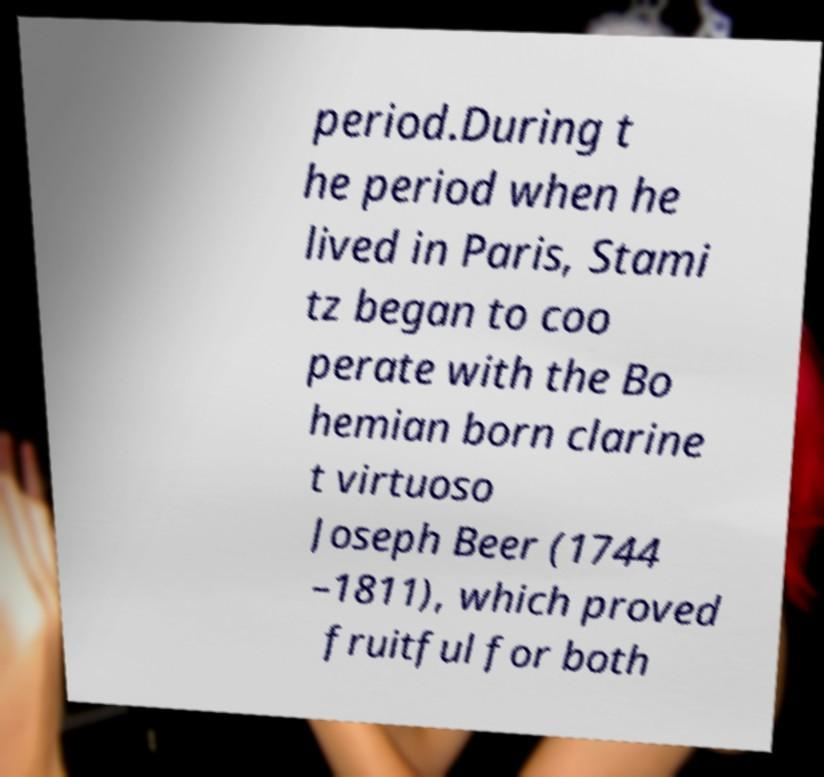Can you read and provide the text displayed in the image?This photo seems to have some interesting text. Can you extract and type it out for me? period.During t he period when he lived in Paris, Stami tz began to coo perate with the Bo hemian born clarine t virtuoso Joseph Beer (1744 –1811), which proved fruitful for both 